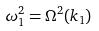Convert formula to latex. <formula><loc_0><loc_0><loc_500><loc_500>\omega _ { 1 } ^ { 2 } = \Omega ^ { 2 } ( k _ { 1 } )</formula> 